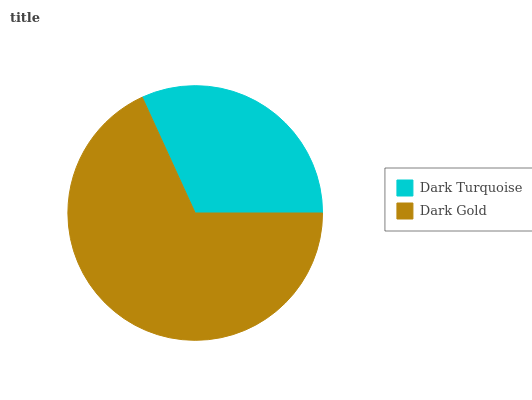Is Dark Turquoise the minimum?
Answer yes or no. Yes. Is Dark Gold the maximum?
Answer yes or no. Yes. Is Dark Gold the minimum?
Answer yes or no. No. Is Dark Gold greater than Dark Turquoise?
Answer yes or no. Yes. Is Dark Turquoise less than Dark Gold?
Answer yes or no. Yes. Is Dark Turquoise greater than Dark Gold?
Answer yes or no. No. Is Dark Gold less than Dark Turquoise?
Answer yes or no. No. Is Dark Gold the high median?
Answer yes or no. Yes. Is Dark Turquoise the low median?
Answer yes or no. Yes. Is Dark Turquoise the high median?
Answer yes or no. No. Is Dark Gold the low median?
Answer yes or no. No. 